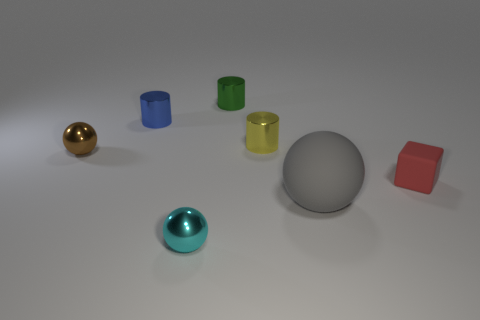What is the material of the large sphere that is on the right side of the tiny object left of the cylinder that is left of the green cylinder?
Your response must be concise. Rubber. There is a shiny ball on the left side of the small metallic cylinder on the left side of the tiny green object; what color is it?
Make the answer very short. Brown. How many large objects are gray rubber things or brown shiny things?
Provide a short and direct response. 1. What number of blocks are the same material as the small cyan object?
Make the answer very short. 0. What size is the metal ball behind the cyan shiny object?
Offer a terse response. Small. There is a matte thing that is behind the ball right of the green cylinder; what shape is it?
Make the answer very short. Cube. There is a rubber object that is behind the sphere that is to the right of the small yellow metallic cylinder; how many small blue things are behind it?
Your response must be concise. 1. Are there fewer small blue objects to the right of the small green metallic cylinder than gray cylinders?
Ensure brevity in your answer.  No. Are there any other things that are the same shape as the brown shiny object?
Provide a short and direct response. Yes. The small object right of the large rubber ball has what shape?
Your answer should be compact. Cube. 